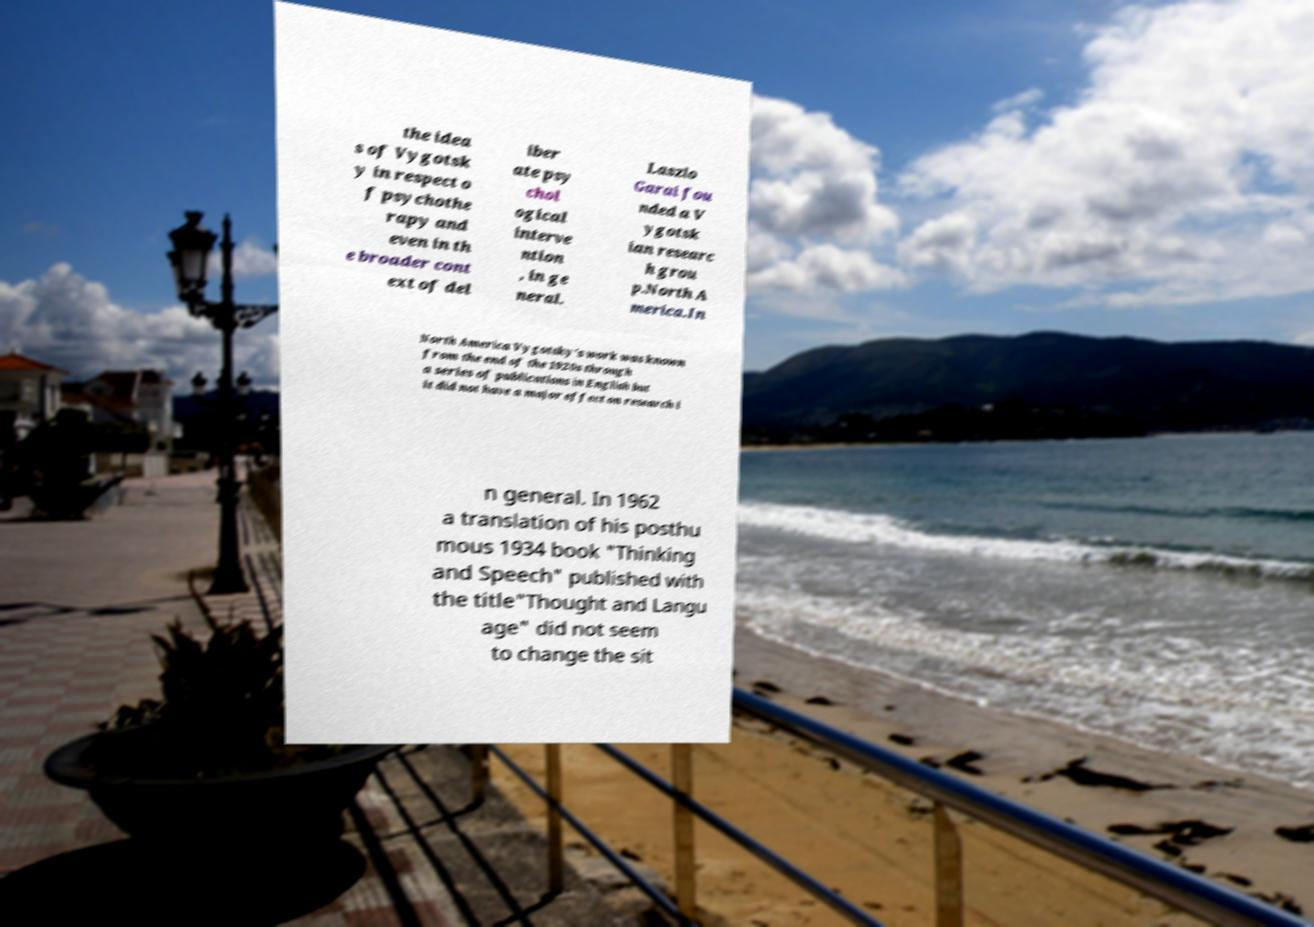There's text embedded in this image that I need extracted. Can you transcribe it verbatim? the idea s of Vygotsk y in respect o f psychothe rapy and even in th e broader cont ext of del iber ate psy chol ogical interve ntion , in ge neral. Laszlo Garai fou nded a V ygotsk ian researc h grou p.North A merica.In North America Vygotsky's work was known from the end of the 1920s through a series of publications in English but it did not have a major effect on research i n general. In 1962 a translation of his posthu mous 1934 book "Thinking and Speech" published with the title"Thought and Langu age" did not seem to change the sit 